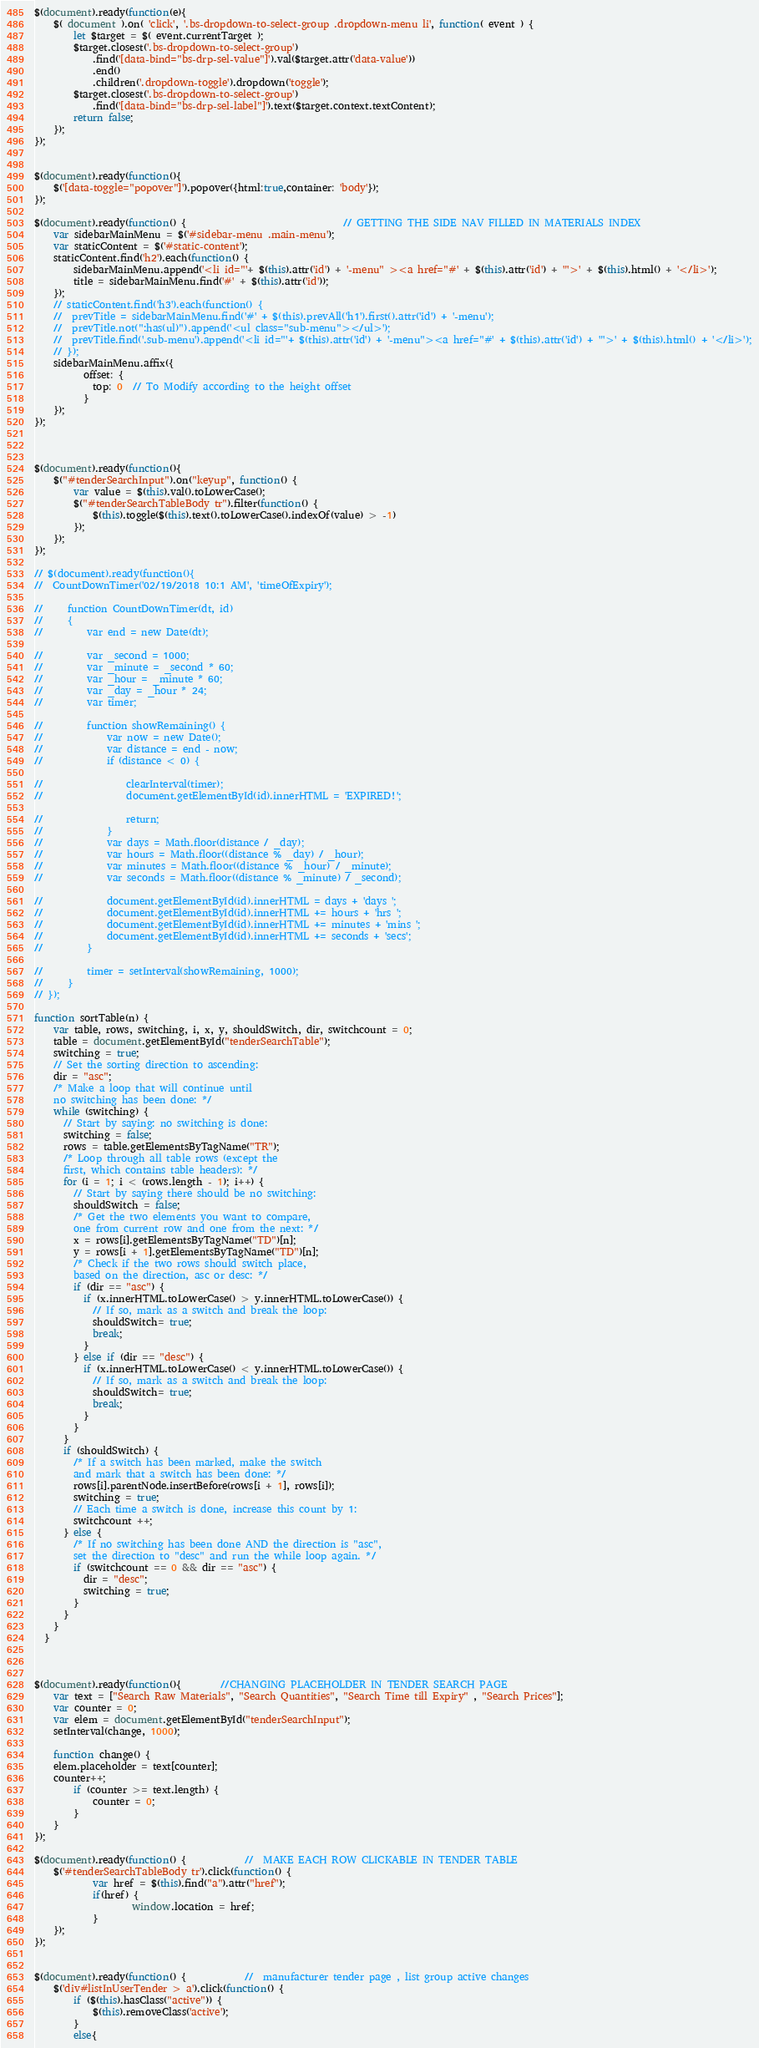Convert code to text. <code><loc_0><loc_0><loc_500><loc_500><_JavaScript_>$(document).ready(function(e){
    $( document ).on( 'click', '.bs-dropdown-to-select-group .dropdown-menu li', function( event ) {
    	let $target = $( event.currentTarget );
		$target.closest('.bs-dropdown-to-select-group')
			.find('[data-bind="bs-drp-sel-value"]').val($target.attr('data-value'))
			.end()
			.children('.dropdown-toggle').dropdown('toggle');
		$target.closest('.bs-dropdown-to-select-group')
    		.find('[data-bind="bs-drp-sel-label"]').text($target.context.textContent);
		return false;
	});
});


$(document).ready(function(){
    $('[data-toggle="popover"]').popover({html:true,container: 'body'});   
});

$(document).ready(function() { 								// GETTING THE SIDE NAV FILLED IN MATERIALS INDEX
    var sidebarMainMenu = $('#sidebar-menu .main-menu');
	var staticContent = $('#static-content');
	staticContent.find('h2').each(function() {
		sidebarMainMenu.append('<li id="'+ $(this).attr('id') + '-menu" ><a href="#' + $(this).attr('id') + '">' + $(this).html() + '</li>');
		title = sidebarMainMenu.find('#' + $(this).attr('id'));
	});
	// staticContent.find('h3').each(function() {
	// 	prevTitle = sidebarMainMenu.find('#' + $(this).prevAll('h1').first().attr('id') + '-menu');
	// 	prevTitle.not(":has(ul)").append('<ul class="sub-menu"></ul>');
	// 	prevTitle.find('.sub-menu').append('<li id="'+ $(this).attr('id') + '-menu"><a href="#' + $(this).attr('id') + '">' + $(this).html() + '</li>');
	// });
	sidebarMainMenu.affix({
	      offset: {
	        top: 0  // To Modify according to the height offset
	      }
	});
});



$(document).ready(function(){
	$("#tenderSearchInput").on("keyup", function() {
		var value = $(this).val().toLowerCase();
		$("#tenderSearchTableBody tr").filter(function() {
			$(this).toggle($(this).text().toLowerCase().indexOf(value) > -1)
		});
	});
});

// $(document).ready(function(){
// 	CountDownTimer('02/19/2018 10:1 AM', 'timeOfExpiry');

//     function CountDownTimer(dt, id)
//     {
//         var end = new Date(dt);

//         var _second = 1000;
//         var _minute = _second * 60;
//         var _hour = _minute * 60;
//         var _day = _hour * 24;
//         var timer;

//         function showRemaining() {
//             var now = new Date();
//             var distance = end - now;
//             if (distance < 0) {

//                 clearInterval(timer);
//                 document.getElementById(id).innerHTML = 'EXPIRED!';

//                 return;
//             }
//             var days = Math.floor(distance / _day);
//             var hours = Math.floor((distance % _day) / _hour);
//             var minutes = Math.floor((distance % _hour) / _minute);
//             var seconds = Math.floor((distance % _minute) / _second);

//             document.getElementById(id).innerHTML = days + 'days ';
//             document.getElementById(id).innerHTML += hours + 'hrs ';
//             document.getElementById(id).innerHTML += minutes + 'mins ';
//             document.getElementById(id).innerHTML += seconds + 'secs';
//         }

//         timer = setInterval(showRemaining, 1000);
//     }
// });

function sortTable(n) {
	var table, rows, switching, i, x, y, shouldSwitch, dir, switchcount = 0;
	table = document.getElementById("tenderSearchTable");
	switching = true;
	// Set the sorting direction to ascending:
	dir = "asc";
	/* Make a loop that will continue until
	no switching has been done: */
	while (switching) {
	  // Start by saying: no switching is done:
	  switching = false;
	  rows = table.getElementsByTagName("TR");
	  /* Loop through all table rows (except the
	  first, which contains table headers): */
	  for (i = 1; i < (rows.length - 1); i++) {
		// Start by saying there should be no switching:
		shouldSwitch = false;
		/* Get the two elements you want to compare,
		one from current row and one from the next: */
		x = rows[i].getElementsByTagName("TD")[n];
		y = rows[i + 1].getElementsByTagName("TD")[n];
		/* Check if the two rows should switch place,
		based on the direction, asc or desc: */
		if (dir == "asc") {
		  if (x.innerHTML.toLowerCase() > y.innerHTML.toLowerCase()) {
			// If so, mark as a switch and break the loop:
			shouldSwitch= true;
			break;
		  }
		} else if (dir == "desc") {
		  if (x.innerHTML.toLowerCase() < y.innerHTML.toLowerCase()) {
			// If so, mark as a switch and break the loop:
			shouldSwitch= true;
			break;
		  }
		}
	  }
	  if (shouldSwitch) {
		/* If a switch has been marked, make the switch
		and mark that a switch has been done: */
		rows[i].parentNode.insertBefore(rows[i + 1], rows[i]);
		switching = true;
		// Each time a switch is done, increase this count by 1:
		switchcount ++;
	  } else {
		/* If no switching has been done AND the direction is "asc",
		set the direction to "desc" and run the while loop again. */
		if (switchcount == 0 && dir == "asc") {
		  dir = "desc";
		  switching = true;
		}
	  }
	}
  }


 
$(document).ready(function(){		//CHANGING PLACEHOLDER IN TENDER SEARCH PAGE
	var text = ["Search Raw Materials", "Search Quantities", "Search Time till Expiry" , "Search Prices"];
	var counter = 0;
	var elem = document.getElementById("tenderSearchInput");
	setInterval(change, 1000);

	function change() {
	elem.placeholder = text[counter];
	counter++;
		if (counter >= text.length) {
			counter = 0;
		}
	}
});

$(document).ready(function() {			//	MAKE EACH ROW CLICKABLE IN TENDER TABLE
	$('#tenderSearchTableBody tr').click(function() {
			var href = $(this).find("a").attr("href");
			if(href) {
					window.location = href;
			}
	});
});


$(document).ready(function() {			//	manufacturer tender page , list group active changes
	$('div#listInUserTender > a').click(function() {
		if ($(this).hasClass("active")) {
			$(this).removeClass('active');
		}
		else{</code> 